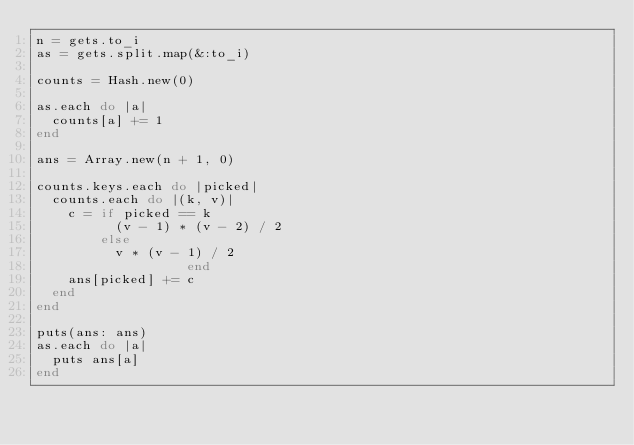<code> <loc_0><loc_0><loc_500><loc_500><_Ruby_>n = gets.to_i
as = gets.split.map(&:to_i)

counts = Hash.new(0)

as.each do |a|
  counts[a] += 1
end

ans = Array.new(n + 1, 0)

counts.keys.each do |picked|
  counts.each do |(k, v)|
    c = if picked == k
          (v - 1) * (v - 2) / 2
        else
          v * (v - 1) / 2
                   end
    ans[picked] += c
  end
end

puts(ans: ans)
as.each do |a|
  puts ans[a]
end
</code> 